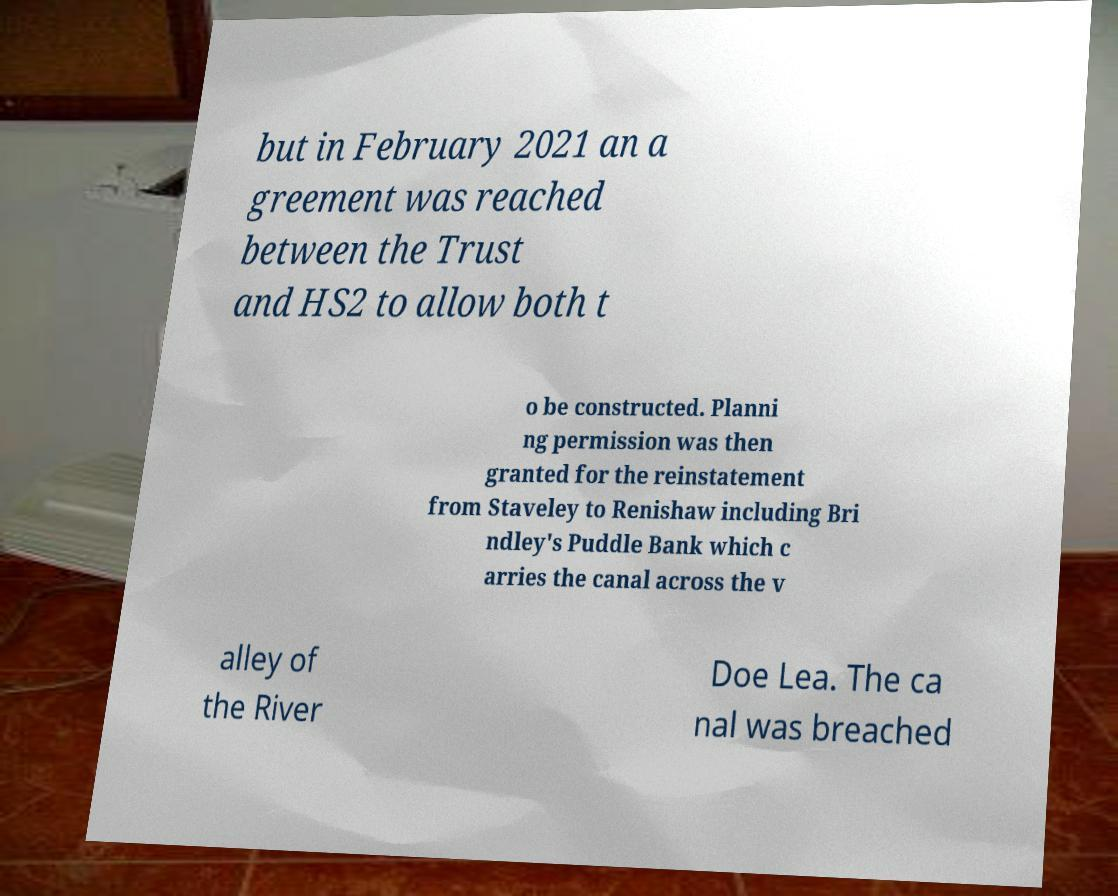Can you accurately transcribe the text from the provided image for me? but in February 2021 an a greement was reached between the Trust and HS2 to allow both t o be constructed. Planni ng permission was then granted for the reinstatement from Staveley to Renishaw including Bri ndley's Puddle Bank which c arries the canal across the v alley of the River Doe Lea. The ca nal was breached 